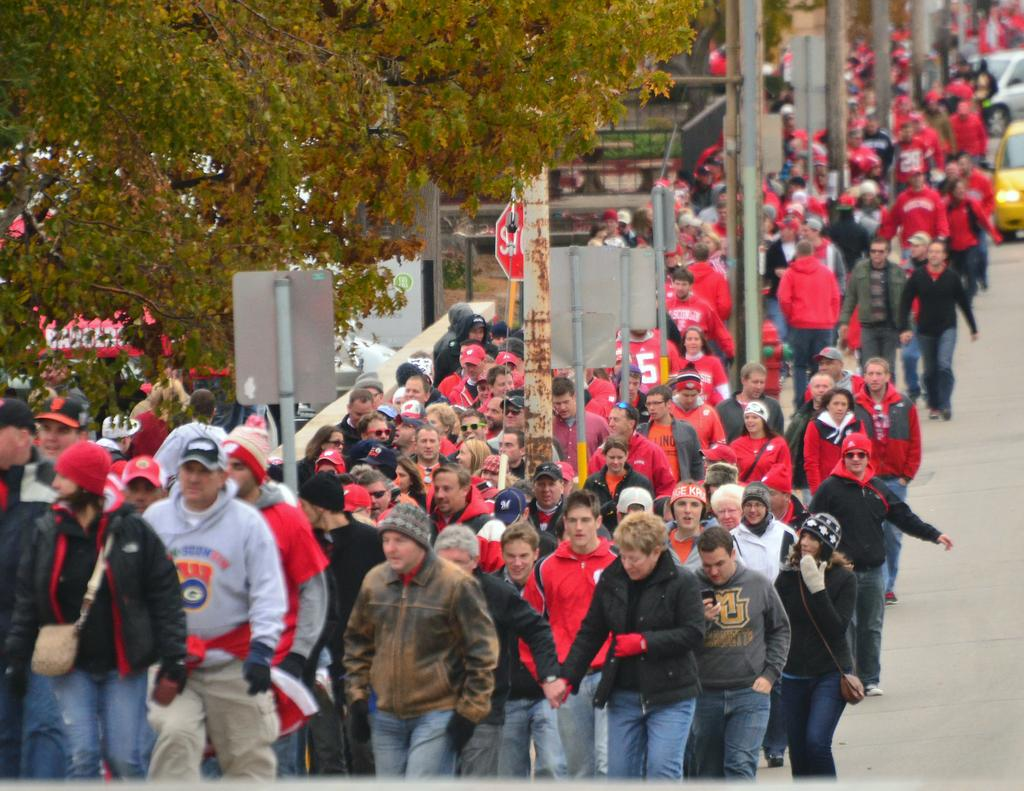What are the people in the image doing? The people in the image are walking on the road. What structures can be seen in the image? There are poles visible in the image. What type of vegetation is present in the image? There are trees in the image. What vehicles can be seen in the image? There are cars on the right side of the image. What is the main surface visible in the image? The bottom of the image shows a road. What type of care is being provided to the rock in the image? There is no rock present in the image, and therefore no care is being provided. What type of oil is being used to lubricate the poles in the image? There is no oil or lubrication mentioned in the image; the poles are simply standing upright. 